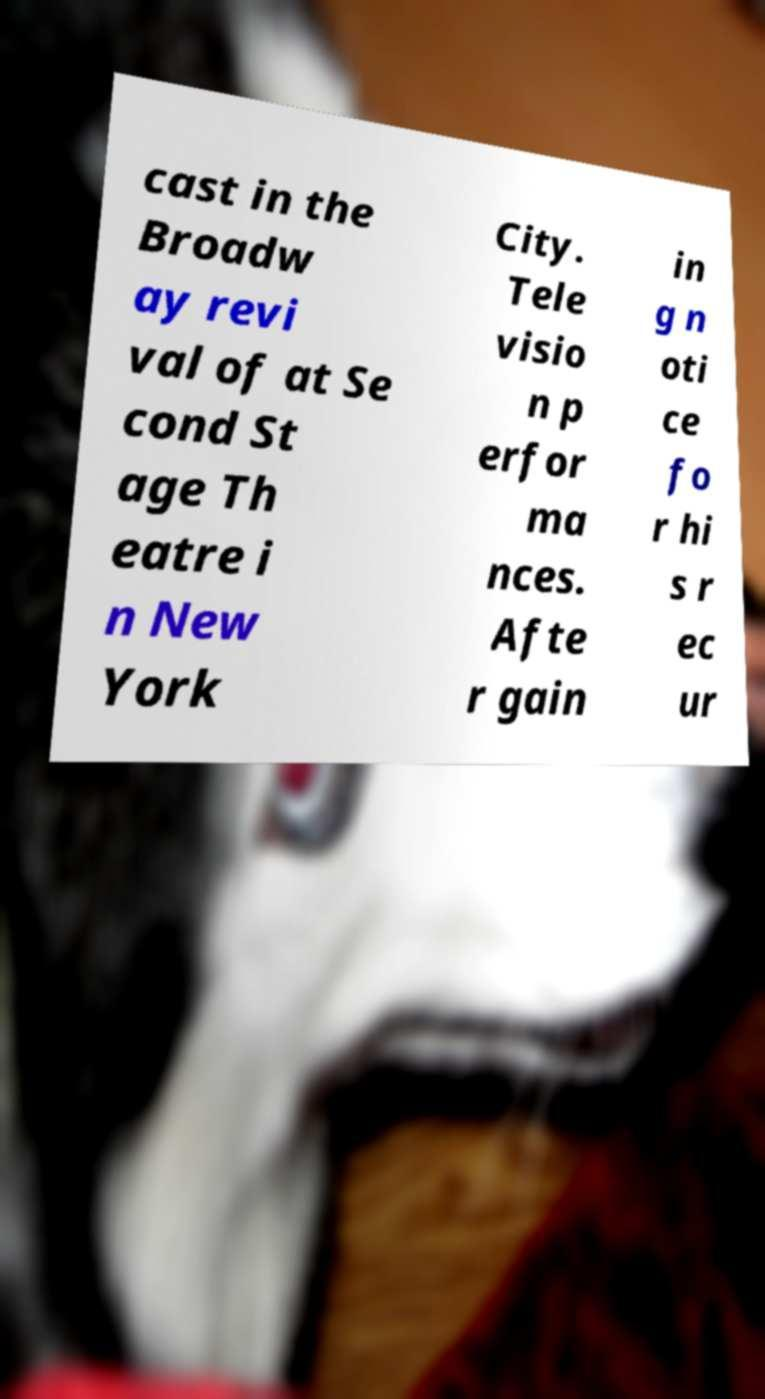What messages or text are displayed in this image? I need them in a readable, typed format. cast in the Broadw ay revi val of at Se cond St age Th eatre i n New York City. Tele visio n p erfor ma nces. Afte r gain in g n oti ce fo r hi s r ec ur 